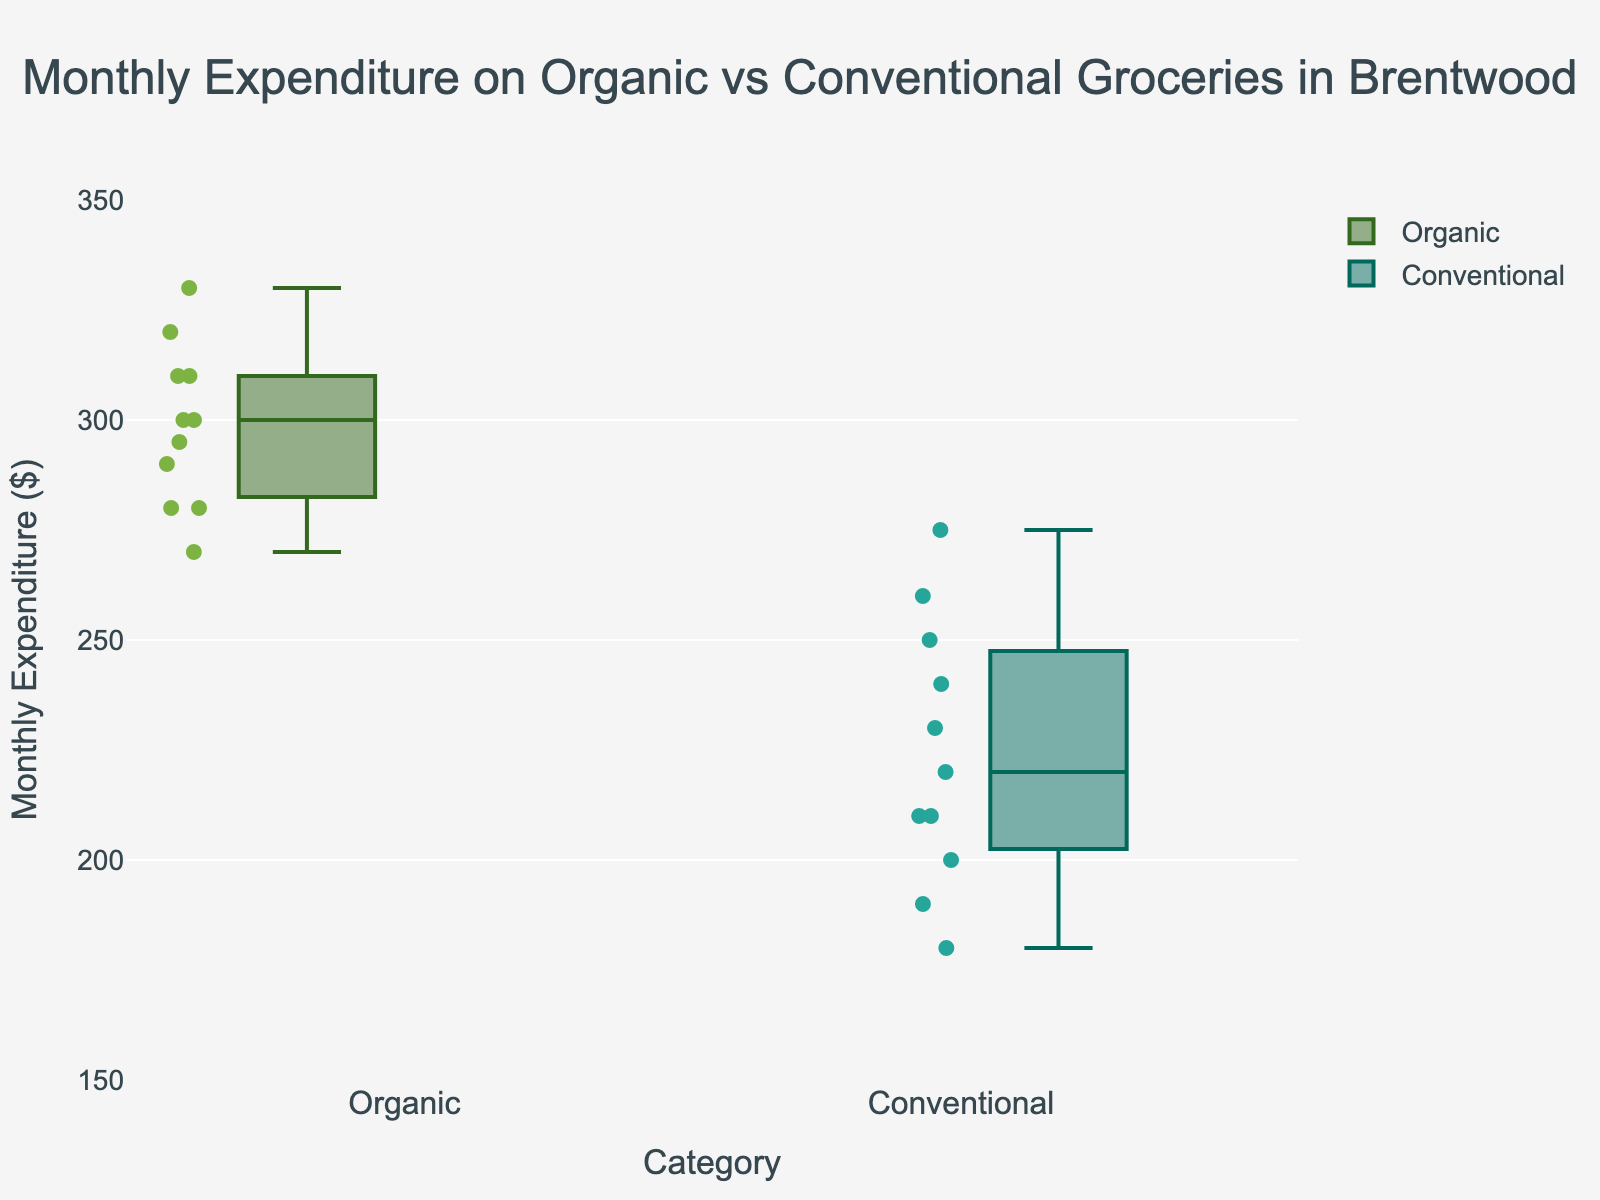What is the title of the plot? The title is displayed at the top of the plot in large, bold text with a clear font.
Answer: Monthly Expenditure on Organic vs Conventional Groceries in Brentwood What are the categories compared in the plot? The figure compares two categories which are indicated on the x-axis.
Answer: Organic and Conventional What is the y-axis title of the plot? The title of the y-axis is located along the vertical axis on the left-hand side.
Answer: Monthly Expenditure ($) Which category shows higher median monthly expenditure? The median value is typically the line inside the box in a box plot. By comparing the positions of these lines, you can determine which category has the higher median.
Answer: Organic What is the range of the y-axis values in the plot? The y-axis range is indicated by the numerical values which extend from the lowest to the highest point visible on the axis.
Answer: 150 to 350 How many households' expenditures are shown for each category? Each scatter point represents an individual household's monthly expenditure. Count the number of scatter points for each category.
Answer: 10 What is the median monthly expenditure for Organic groceries? Locate the line inside the box for Organic. This line represents the median value.
Answer: Around 300 What is the difference between the median expenses on Organic and Conventional groceries? First, find the median values for both categories. Then subtract the median of Conventional from the median of Organic.
Answer: 80 (300-220) Which household has the highest monthly expenditure on Organic groceries? Look for the highest scatter point within the Organic category. Check the associated household name from the data.
Answer: Harris Family Is there more variability in the expenditure on Organic or Conventional groceries? Variability can often be visualized by the spread of the points and size of the box in a box plot. The category with the larger spread and a larger box shows more variability.
Answer: Organic 